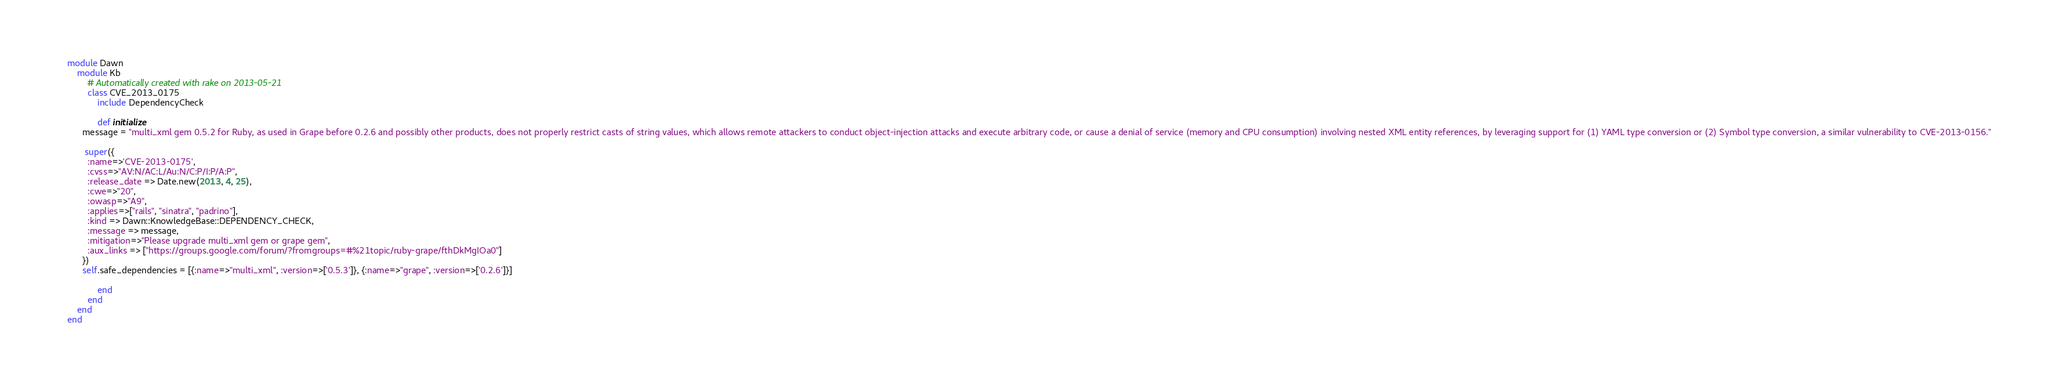<code> <loc_0><loc_0><loc_500><loc_500><_Ruby_>	module Dawn
		module Kb
			# Automatically created with rake on 2013-05-21
			class CVE_2013_0175
				include DependencyCheck

				def initialize
          message = "multi_xml gem 0.5.2 for Ruby, as used in Grape before 0.2.6 and possibly other products, does not properly restrict casts of string values, which allows remote attackers to conduct object-injection attacks and execute arbitrary code, or cause a denial of service (memory and CPU consumption) involving nested XML entity references, by leveraging support for (1) YAML type conversion or (2) Symbol type conversion, a similar vulnerability to CVE-2013-0156."

           super({
            :name=>'CVE-2013-0175', 
            :cvss=>"AV:N/AC:L/Au:N/C:P/I:P/A:P",  
            :release_date => Date.new(2013, 4, 25),
            :cwe=>"20", 
            :owasp=>"A9",
            :applies=>["rails", "sinatra", "padrino"],
            :kind => Dawn::KnowledgeBase::DEPENDENCY_CHECK,
            :message => message,
            :mitigation=>"Please upgrade multi_xml gem or grape gem",
            :aux_links => ["https://groups.google.com/forum/?fromgroups=#%21topic/ruby-grape/fthDkMgIOa0"]
          })
          self.safe_dependencies = [{:name=>"multi_xml", :version=>['0.5.3']}, {:name=>"grape", :version=>['0.2.6']}]

				end
			end
		end
	end
</code> 